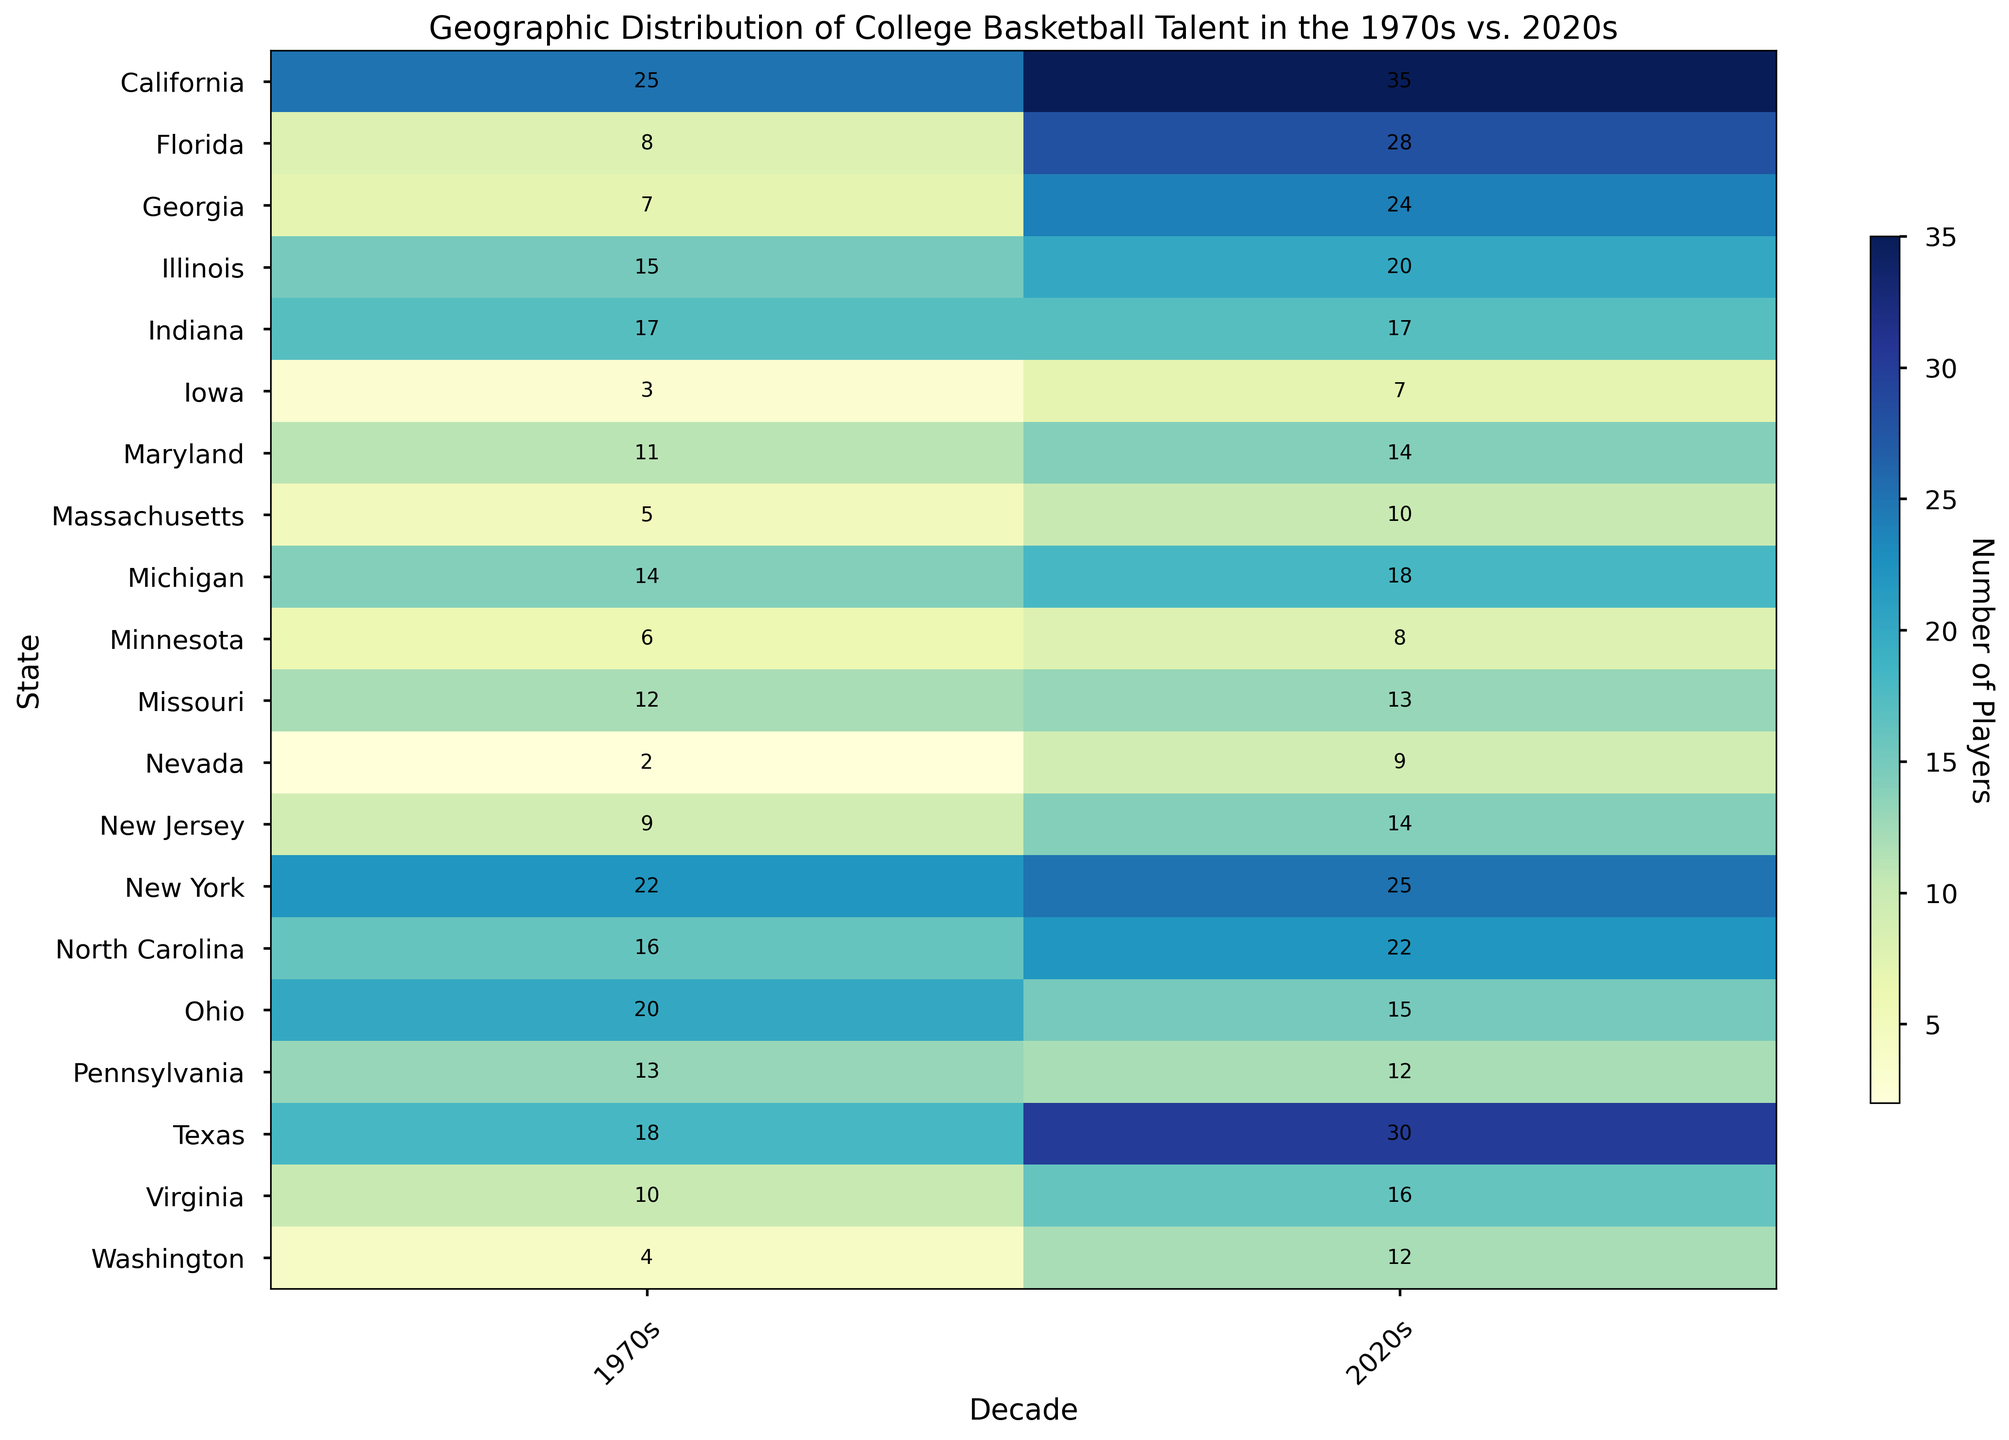Which state had the greatest increase in the number of college basketball players from the 1970s to the 2020s? Compare the number of players in each state for the two decades and find the difference. The greatest increase is in California, with an increase from 25 to 35 players.
Answer: California Which state saw a decrease in the number of college basketball players from the 1970s to the 2020s? Review each state's numbers for both decades and identify if any state's count in the 2020s is less than in the 1970s. Ohio declined from 20 to 15 players.
Answer: Ohio Which state had the highest number of college basketball players in the 1970s? Look at the top values in the 1970s column of the heatmap. California had the highest number of players with 25.
Answer: California Which two states had equal numbers of college basketball players in the 1970s and 2020s? Compare the counts for both decades and identify any states with equal counts. Indiana had equal counts of 17 in both decades.
Answer: Indiana What's the total number of college basketball players from Florida in both decades? Add the number of players from Florida in the 1970s and 2020s. Florida had 8 in the 1970s and 28 in the 2020s, so 8 + 28 = 36.
Answer: 36 In which decade did Pennsylvania have more basketball players? Compare the values for Pennsylvania in both decades. There were more players in the 1970s (13) compared to the 2020s (12).
Answer: 1970s Which state had the smallest number of college basketball players in the 1970s, and how many players were there? Review the 1970s column for the lowest count. Nevada had the smallest number with 2 players.
Answer: Nevada, 2 Which state had the largest increase in the number of players from the 1970s to the 2020s besides California? Calculate the increases for each state and find the largest one after California. Florida increased from 8 to 28 players, a difference of 20.
Answer: Florida Considering the heatmap, what is the average number of college basketball players across all states for the 2020s? Add the number of players for each state in the 2020s and divide by the number of states (20). (35 + 30 + 25 + 20 + 15 + 28 + 12 + 22 + 24 + 18 + 17 + 10 + 14 + 16 + 14 + 12 + 9 + 8 + 7 + 13) = 349; 349 ÷ 20 = 17.45.
Answer: 17.45 